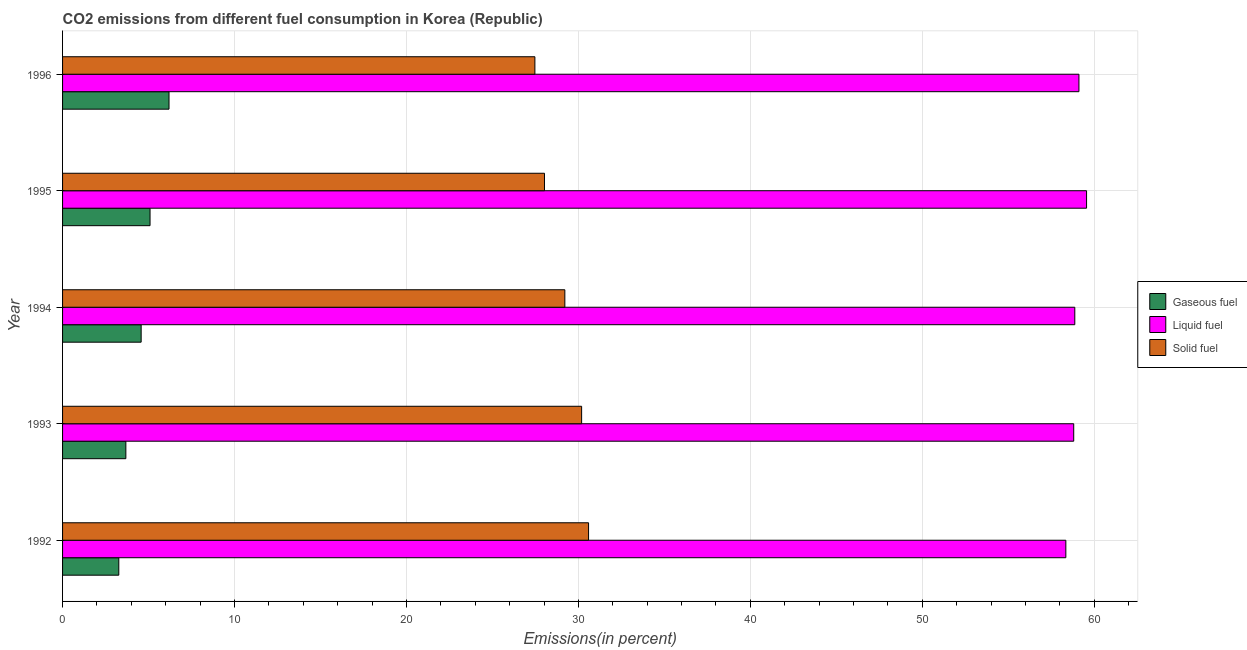Are the number of bars per tick equal to the number of legend labels?
Provide a short and direct response. Yes. Are the number of bars on each tick of the Y-axis equal?
Your answer should be very brief. Yes. How many bars are there on the 4th tick from the top?
Keep it short and to the point. 3. What is the label of the 3rd group of bars from the top?
Provide a short and direct response. 1994. What is the percentage of liquid fuel emission in 1992?
Offer a terse response. 58.35. Across all years, what is the maximum percentage of gaseous fuel emission?
Ensure brevity in your answer.  6.19. Across all years, what is the minimum percentage of solid fuel emission?
Make the answer very short. 27.47. In which year was the percentage of gaseous fuel emission maximum?
Give a very brief answer. 1996. In which year was the percentage of liquid fuel emission minimum?
Your answer should be compact. 1992. What is the total percentage of gaseous fuel emission in the graph?
Your answer should be very brief. 22.8. What is the difference between the percentage of gaseous fuel emission in 1994 and that in 1996?
Provide a succinct answer. -1.62. What is the difference between the percentage of liquid fuel emission in 1992 and the percentage of gaseous fuel emission in 1994?
Provide a short and direct response. 53.78. What is the average percentage of gaseous fuel emission per year?
Keep it short and to the point. 4.56. In the year 1995, what is the difference between the percentage of solid fuel emission and percentage of liquid fuel emission?
Offer a very short reply. -31.52. In how many years, is the percentage of solid fuel emission greater than 4 %?
Make the answer very short. 5. What is the ratio of the percentage of gaseous fuel emission in 1992 to that in 1995?
Offer a very short reply. 0.64. Is the difference between the percentage of gaseous fuel emission in 1993 and 1995 greater than the difference between the percentage of solid fuel emission in 1993 and 1995?
Offer a terse response. No. What is the difference between the highest and the second highest percentage of solid fuel emission?
Your answer should be compact. 0.4. What is the difference between the highest and the lowest percentage of gaseous fuel emission?
Make the answer very short. 2.92. In how many years, is the percentage of solid fuel emission greater than the average percentage of solid fuel emission taken over all years?
Offer a terse response. 3. What does the 3rd bar from the top in 1994 represents?
Make the answer very short. Gaseous fuel. What does the 3rd bar from the bottom in 1993 represents?
Offer a very short reply. Solid fuel. Is it the case that in every year, the sum of the percentage of gaseous fuel emission and percentage of liquid fuel emission is greater than the percentage of solid fuel emission?
Keep it short and to the point. Yes. How many bars are there?
Ensure brevity in your answer.  15. Are all the bars in the graph horizontal?
Give a very brief answer. Yes. Does the graph contain any zero values?
Provide a short and direct response. No. Does the graph contain grids?
Offer a very short reply. Yes. How many legend labels are there?
Offer a very short reply. 3. What is the title of the graph?
Ensure brevity in your answer.  CO2 emissions from different fuel consumption in Korea (Republic). Does "Solid fuel" appear as one of the legend labels in the graph?
Give a very brief answer. Yes. What is the label or title of the X-axis?
Offer a terse response. Emissions(in percent). What is the Emissions(in percent) in Gaseous fuel in 1992?
Your answer should be compact. 3.27. What is the Emissions(in percent) in Liquid fuel in 1992?
Make the answer very short. 58.35. What is the Emissions(in percent) of Solid fuel in 1992?
Your answer should be compact. 30.59. What is the Emissions(in percent) in Gaseous fuel in 1993?
Provide a short and direct response. 3.68. What is the Emissions(in percent) in Liquid fuel in 1993?
Give a very brief answer. 58.8. What is the Emissions(in percent) in Solid fuel in 1993?
Your response must be concise. 30.19. What is the Emissions(in percent) in Gaseous fuel in 1994?
Keep it short and to the point. 4.57. What is the Emissions(in percent) of Liquid fuel in 1994?
Make the answer very short. 58.87. What is the Emissions(in percent) of Solid fuel in 1994?
Offer a terse response. 29.21. What is the Emissions(in percent) of Gaseous fuel in 1995?
Give a very brief answer. 5.09. What is the Emissions(in percent) of Liquid fuel in 1995?
Provide a succinct answer. 59.55. What is the Emissions(in percent) of Solid fuel in 1995?
Ensure brevity in your answer.  28.03. What is the Emissions(in percent) in Gaseous fuel in 1996?
Make the answer very short. 6.19. What is the Emissions(in percent) in Liquid fuel in 1996?
Make the answer very short. 59.11. What is the Emissions(in percent) of Solid fuel in 1996?
Your answer should be very brief. 27.47. Across all years, what is the maximum Emissions(in percent) in Gaseous fuel?
Ensure brevity in your answer.  6.19. Across all years, what is the maximum Emissions(in percent) in Liquid fuel?
Your answer should be compact. 59.55. Across all years, what is the maximum Emissions(in percent) in Solid fuel?
Your answer should be compact. 30.59. Across all years, what is the minimum Emissions(in percent) in Gaseous fuel?
Offer a very short reply. 3.27. Across all years, what is the minimum Emissions(in percent) of Liquid fuel?
Ensure brevity in your answer.  58.35. Across all years, what is the minimum Emissions(in percent) in Solid fuel?
Ensure brevity in your answer.  27.47. What is the total Emissions(in percent) in Gaseous fuel in the graph?
Keep it short and to the point. 22.8. What is the total Emissions(in percent) in Liquid fuel in the graph?
Make the answer very short. 294.67. What is the total Emissions(in percent) of Solid fuel in the graph?
Provide a succinct answer. 145.48. What is the difference between the Emissions(in percent) in Gaseous fuel in 1992 and that in 1993?
Ensure brevity in your answer.  -0.41. What is the difference between the Emissions(in percent) of Liquid fuel in 1992 and that in 1993?
Offer a very short reply. -0.46. What is the difference between the Emissions(in percent) of Solid fuel in 1992 and that in 1993?
Your response must be concise. 0.4. What is the difference between the Emissions(in percent) of Gaseous fuel in 1992 and that in 1994?
Ensure brevity in your answer.  -1.3. What is the difference between the Emissions(in percent) in Liquid fuel in 1992 and that in 1994?
Offer a terse response. -0.52. What is the difference between the Emissions(in percent) in Solid fuel in 1992 and that in 1994?
Ensure brevity in your answer.  1.38. What is the difference between the Emissions(in percent) of Gaseous fuel in 1992 and that in 1995?
Give a very brief answer. -1.82. What is the difference between the Emissions(in percent) in Liquid fuel in 1992 and that in 1995?
Make the answer very short. -1.2. What is the difference between the Emissions(in percent) in Solid fuel in 1992 and that in 1995?
Keep it short and to the point. 2.56. What is the difference between the Emissions(in percent) in Gaseous fuel in 1992 and that in 1996?
Offer a terse response. -2.92. What is the difference between the Emissions(in percent) of Liquid fuel in 1992 and that in 1996?
Offer a very short reply. -0.76. What is the difference between the Emissions(in percent) of Solid fuel in 1992 and that in 1996?
Your response must be concise. 3.12. What is the difference between the Emissions(in percent) of Gaseous fuel in 1993 and that in 1994?
Your answer should be compact. -0.89. What is the difference between the Emissions(in percent) of Liquid fuel in 1993 and that in 1994?
Keep it short and to the point. -0.06. What is the difference between the Emissions(in percent) in Solid fuel in 1993 and that in 1994?
Offer a very short reply. 0.98. What is the difference between the Emissions(in percent) of Gaseous fuel in 1993 and that in 1995?
Your answer should be compact. -1.41. What is the difference between the Emissions(in percent) in Liquid fuel in 1993 and that in 1995?
Provide a succinct answer. -0.75. What is the difference between the Emissions(in percent) of Solid fuel in 1993 and that in 1995?
Offer a very short reply. 2.16. What is the difference between the Emissions(in percent) in Gaseous fuel in 1993 and that in 1996?
Ensure brevity in your answer.  -2.51. What is the difference between the Emissions(in percent) of Liquid fuel in 1993 and that in 1996?
Give a very brief answer. -0.3. What is the difference between the Emissions(in percent) in Solid fuel in 1993 and that in 1996?
Provide a succinct answer. 2.72. What is the difference between the Emissions(in percent) in Gaseous fuel in 1994 and that in 1995?
Your answer should be very brief. -0.52. What is the difference between the Emissions(in percent) of Liquid fuel in 1994 and that in 1995?
Your answer should be compact. -0.68. What is the difference between the Emissions(in percent) in Solid fuel in 1994 and that in 1995?
Ensure brevity in your answer.  1.18. What is the difference between the Emissions(in percent) in Gaseous fuel in 1994 and that in 1996?
Offer a terse response. -1.62. What is the difference between the Emissions(in percent) in Liquid fuel in 1994 and that in 1996?
Your answer should be very brief. -0.24. What is the difference between the Emissions(in percent) of Solid fuel in 1994 and that in 1996?
Your answer should be compact. 1.74. What is the difference between the Emissions(in percent) in Gaseous fuel in 1995 and that in 1996?
Give a very brief answer. -1.1. What is the difference between the Emissions(in percent) of Liquid fuel in 1995 and that in 1996?
Make the answer very short. 0.44. What is the difference between the Emissions(in percent) of Solid fuel in 1995 and that in 1996?
Ensure brevity in your answer.  0.56. What is the difference between the Emissions(in percent) of Gaseous fuel in 1992 and the Emissions(in percent) of Liquid fuel in 1993?
Make the answer very short. -55.53. What is the difference between the Emissions(in percent) of Gaseous fuel in 1992 and the Emissions(in percent) of Solid fuel in 1993?
Your answer should be compact. -26.92. What is the difference between the Emissions(in percent) of Liquid fuel in 1992 and the Emissions(in percent) of Solid fuel in 1993?
Give a very brief answer. 28.16. What is the difference between the Emissions(in percent) of Gaseous fuel in 1992 and the Emissions(in percent) of Liquid fuel in 1994?
Keep it short and to the point. -55.6. What is the difference between the Emissions(in percent) of Gaseous fuel in 1992 and the Emissions(in percent) of Solid fuel in 1994?
Keep it short and to the point. -25.94. What is the difference between the Emissions(in percent) of Liquid fuel in 1992 and the Emissions(in percent) of Solid fuel in 1994?
Your response must be concise. 29.14. What is the difference between the Emissions(in percent) of Gaseous fuel in 1992 and the Emissions(in percent) of Liquid fuel in 1995?
Your response must be concise. -56.28. What is the difference between the Emissions(in percent) in Gaseous fuel in 1992 and the Emissions(in percent) in Solid fuel in 1995?
Your response must be concise. -24.76. What is the difference between the Emissions(in percent) of Liquid fuel in 1992 and the Emissions(in percent) of Solid fuel in 1995?
Provide a short and direct response. 30.32. What is the difference between the Emissions(in percent) in Gaseous fuel in 1992 and the Emissions(in percent) in Liquid fuel in 1996?
Your answer should be compact. -55.84. What is the difference between the Emissions(in percent) of Gaseous fuel in 1992 and the Emissions(in percent) of Solid fuel in 1996?
Your answer should be very brief. -24.2. What is the difference between the Emissions(in percent) of Liquid fuel in 1992 and the Emissions(in percent) of Solid fuel in 1996?
Your response must be concise. 30.88. What is the difference between the Emissions(in percent) in Gaseous fuel in 1993 and the Emissions(in percent) in Liquid fuel in 1994?
Your response must be concise. -55.18. What is the difference between the Emissions(in percent) in Gaseous fuel in 1993 and the Emissions(in percent) in Solid fuel in 1994?
Your answer should be compact. -25.53. What is the difference between the Emissions(in percent) in Liquid fuel in 1993 and the Emissions(in percent) in Solid fuel in 1994?
Your answer should be very brief. 29.59. What is the difference between the Emissions(in percent) of Gaseous fuel in 1993 and the Emissions(in percent) of Liquid fuel in 1995?
Give a very brief answer. -55.87. What is the difference between the Emissions(in percent) of Gaseous fuel in 1993 and the Emissions(in percent) of Solid fuel in 1995?
Your response must be concise. -24.34. What is the difference between the Emissions(in percent) of Liquid fuel in 1993 and the Emissions(in percent) of Solid fuel in 1995?
Offer a terse response. 30.78. What is the difference between the Emissions(in percent) in Gaseous fuel in 1993 and the Emissions(in percent) in Liquid fuel in 1996?
Provide a short and direct response. -55.43. What is the difference between the Emissions(in percent) in Gaseous fuel in 1993 and the Emissions(in percent) in Solid fuel in 1996?
Ensure brevity in your answer.  -23.79. What is the difference between the Emissions(in percent) in Liquid fuel in 1993 and the Emissions(in percent) in Solid fuel in 1996?
Give a very brief answer. 31.34. What is the difference between the Emissions(in percent) of Gaseous fuel in 1994 and the Emissions(in percent) of Liquid fuel in 1995?
Offer a very short reply. -54.98. What is the difference between the Emissions(in percent) of Gaseous fuel in 1994 and the Emissions(in percent) of Solid fuel in 1995?
Your answer should be very brief. -23.46. What is the difference between the Emissions(in percent) of Liquid fuel in 1994 and the Emissions(in percent) of Solid fuel in 1995?
Give a very brief answer. 30.84. What is the difference between the Emissions(in percent) of Gaseous fuel in 1994 and the Emissions(in percent) of Liquid fuel in 1996?
Ensure brevity in your answer.  -54.54. What is the difference between the Emissions(in percent) of Gaseous fuel in 1994 and the Emissions(in percent) of Solid fuel in 1996?
Offer a very short reply. -22.9. What is the difference between the Emissions(in percent) in Liquid fuel in 1994 and the Emissions(in percent) in Solid fuel in 1996?
Provide a succinct answer. 31.4. What is the difference between the Emissions(in percent) in Gaseous fuel in 1995 and the Emissions(in percent) in Liquid fuel in 1996?
Keep it short and to the point. -54.02. What is the difference between the Emissions(in percent) of Gaseous fuel in 1995 and the Emissions(in percent) of Solid fuel in 1996?
Make the answer very short. -22.38. What is the difference between the Emissions(in percent) of Liquid fuel in 1995 and the Emissions(in percent) of Solid fuel in 1996?
Give a very brief answer. 32.08. What is the average Emissions(in percent) of Gaseous fuel per year?
Your answer should be compact. 4.56. What is the average Emissions(in percent) of Liquid fuel per year?
Offer a terse response. 58.93. What is the average Emissions(in percent) of Solid fuel per year?
Keep it short and to the point. 29.1. In the year 1992, what is the difference between the Emissions(in percent) of Gaseous fuel and Emissions(in percent) of Liquid fuel?
Your answer should be compact. -55.08. In the year 1992, what is the difference between the Emissions(in percent) in Gaseous fuel and Emissions(in percent) in Solid fuel?
Provide a short and direct response. -27.32. In the year 1992, what is the difference between the Emissions(in percent) of Liquid fuel and Emissions(in percent) of Solid fuel?
Your answer should be compact. 27.76. In the year 1993, what is the difference between the Emissions(in percent) of Gaseous fuel and Emissions(in percent) of Liquid fuel?
Offer a terse response. -55.12. In the year 1993, what is the difference between the Emissions(in percent) in Gaseous fuel and Emissions(in percent) in Solid fuel?
Provide a short and direct response. -26.5. In the year 1993, what is the difference between the Emissions(in percent) in Liquid fuel and Emissions(in percent) in Solid fuel?
Ensure brevity in your answer.  28.62. In the year 1994, what is the difference between the Emissions(in percent) in Gaseous fuel and Emissions(in percent) in Liquid fuel?
Your answer should be compact. -54.3. In the year 1994, what is the difference between the Emissions(in percent) in Gaseous fuel and Emissions(in percent) in Solid fuel?
Give a very brief answer. -24.64. In the year 1994, what is the difference between the Emissions(in percent) in Liquid fuel and Emissions(in percent) in Solid fuel?
Give a very brief answer. 29.66. In the year 1995, what is the difference between the Emissions(in percent) in Gaseous fuel and Emissions(in percent) in Liquid fuel?
Provide a short and direct response. -54.46. In the year 1995, what is the difference between the Emissions(in percent) of Gaseous fuel and Emissions(in percent) of Solid fuel?
Offer a very short reply. -22.94. In the year 1995, what is the difference between the Emissions(in percent) of Liquid fuel and Emissions(in percent) of Solid fuel?
Provide a short and direct response. 31.52. In the year 1996, what is the difference between the Emissions(in percent) of Gaseous fuel and Emissions(in percent) of Liquid fuel?
Give a very brief answer. -52.92. In the year 1996, what is the difference between the Emissions(in percent) in Gaseous fuel and Emissions(in percent) in Solid fuel?
Keep it short and to the point. -21.28. In the year 1996, what is the difference between the Emissions(in percent) of Liquid fuel and Emissions(in percent) of Solid fuel?
Offer a very short reply. 31.64. What is the ratio of the Emissions(in percent) of Gaseous fuel in 1992 to that in 1993?
Keep it short and to the point. 0.89. What is the ratio of the Emissions(in percent) in Solid fuel in 1992 to that in 1993?
Make the answer very short. 1.01. What is the ratio of the Emissions(in percent) of Gaseous fuel in 1992 to that in 1994?
Offer a very short reply. 0.72. What is the ratio of the Emissions(in percent) of Solid fuel in 1992 to that in 1994?
Offer a very short reply. 1.05. What is the ratio of the Emissions(in percent) of Gaseous fuel in 1992 to that in 1995?
Provide a succinct answer. 0.64. What is the ratio of the Emissions(in percent) of Liquid fuel in 1992 to that in 1995?
Ensure brevity in your answer.  0.98. What is the ratio of the Emissions(in percent) in Solid fuel in 1992 to that in 1995?
Your answer should be compact. 1.09. What is the ratio of the Emissions(in percent) in Gaseous fuel in 1992 to that in 1996?
Offer a terse response. 0.53. What is the ratio of the Emissions(in percent) in Liquid fuel in 1992 to that in 1996?
Offer a very short reply. 0.99. What is the ratio of the Emissions(in percent) in Solid fuel in 1992 to that in 1996?
Provide a short and direct response. 1.11. What is the ratio of the Emissions(in percent) of Gaseous fuel in 1993 to that in 1994?
Provide a succinct answer. 0.81. What is the ratio of the Emissions(in percent) in Liquid fuel in 1993 to that in 1994?
Your response must be concise. 1. What is the ratio of the Emissions(in percent) of Solid fuel in 1993 to that in 1994?
Your answer should be very brief. 1.03. What is the ratio of the Emissions(in percent) of Gaseous fuel in 1993 to that in 1995?
Offer a terse response. 0.72. What is the ratio of the Emissions(in percent) of Liquid fuel in 1993 to that in 1995?
Your answer should be compact. 0.99. What is the ratio of the Emissions(in percent) of Solid fuel in 1993 to that in 1995?
Ensure brevity in your answer.  1.08. What is the ratio of the Emissions(in percent) in Gaseous fuel in 1993 to that in 1996?
Keep it short and to the point. 0.59. What is the ratio of the Emissions(in percent) in Solid fuel in 1993 to that in 1996?
Your answer should be very brief. 1.1. What is the ratio of the Emissions(in percent) of Gaseous fuel in 1994 to that in 1995?
Provide a succinct answer. 0.9. What is the ratio of the Emissions(in percent) of Liquid fuel in 1994 to that in 1995?
Your response must be concise. 0.99. What is the ratio of the Emissions(in percent) in Solid fuel in 1994 to that in 1995?
Keep it short and to the point. 1.04. What is the ratio of the Emissions(in percent) of Gaseous fuel in 1994 to that in 1996?
Make the answer very short. 0.74. What is the ratio of the Emissions(in percent) in Solid fuel in 1994 to that in 1996?
Your response must be concise. 1.06. What is the ratio of the Emissions(in percent) of Gaseous fuel in 1995 to that in 1996?
Ensure brevity in your answer.  0.82. What is the ratio of the Emissions(in percent) of Liquid fuel in 1995 to that in 1996?
Your answer should be compact. 1.01. What is the ratio of the Emissions(in percent) of Solid fuel in 1995 to that in 1996?
Make the answer very short. 1.02. What is the difference between the highest and the second highest Emissions(in percent) of Gaseous fuel?
Provide a short and direct response. 1.1. What is the difference between the highest and the second highest Emissions(in percent) of Liquid fuel?
Provide a succinct answer. 0.44. What is the difference between the highest and the second highest Emissions(in percent) of Solid fuel?
Your response must be concise. 0.4. What is the difference between the highest and the lowest Emissions(in percent) of Gaseous fuel?
Your answer should be compact. 2.92. What is the difference between the highest and the lowest Emissions(in percent) of Liquid fuel?
Give a very brief answer. 1.2. What is the difference between the highest and the lowest Emissions(in percent) in Solid fuel?
Give a very brief answer. 3.12. 